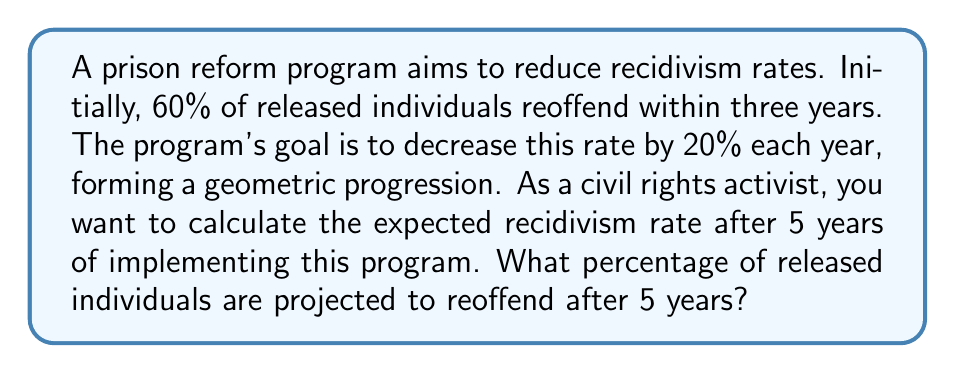Provide a solution to this math problem. Let's approach this step-by-step:

1) The initial recidivism rate is 60% or 0.60.

2) Each year, the rate decreases by 20% of the previous year's rate. This means we multiply by 0.80 (1 - 0.20) each year.

3) We can represent this as a geometric progression with:
   - Initial term: $a = 0.60$
   - Common ratio: $r = 0.80$
   - Number of terms: $n = 5$ (5 years)

4) The formula for the nth term of a geometric progression is:
   $a_n = a \cdot r^{n-1}$

5) Substituting our values:
   $a_5 = 0.60 \cdot (0.80)^{5-1}$

6) Simplify:
   $a_5 = 0.60 \cdot (0.80)^4$

7) Calculate:
   $a_5 = 0.60 \cdot 0.4096 = 0.24576$

8) Convert to percentage:
   $0.24576 \cdot 100\% = 24.576\%$

Therefore, after 5 years, the projected recidivism rate is approximately 24.576%.
Answer: 24.576% 